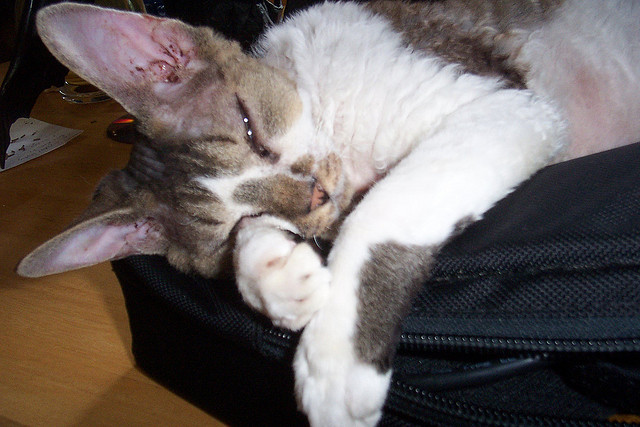<image>What vet treatment does this cat need? It is unknown what vet treatment this cat needs. The answer can range from 'ear cleaning', 'shot', 'ear infection', 'ear mites', 'pink eye', or 'exam'. What vet treatment does this cat need? It is unknown what vet treatment this cat needs. 